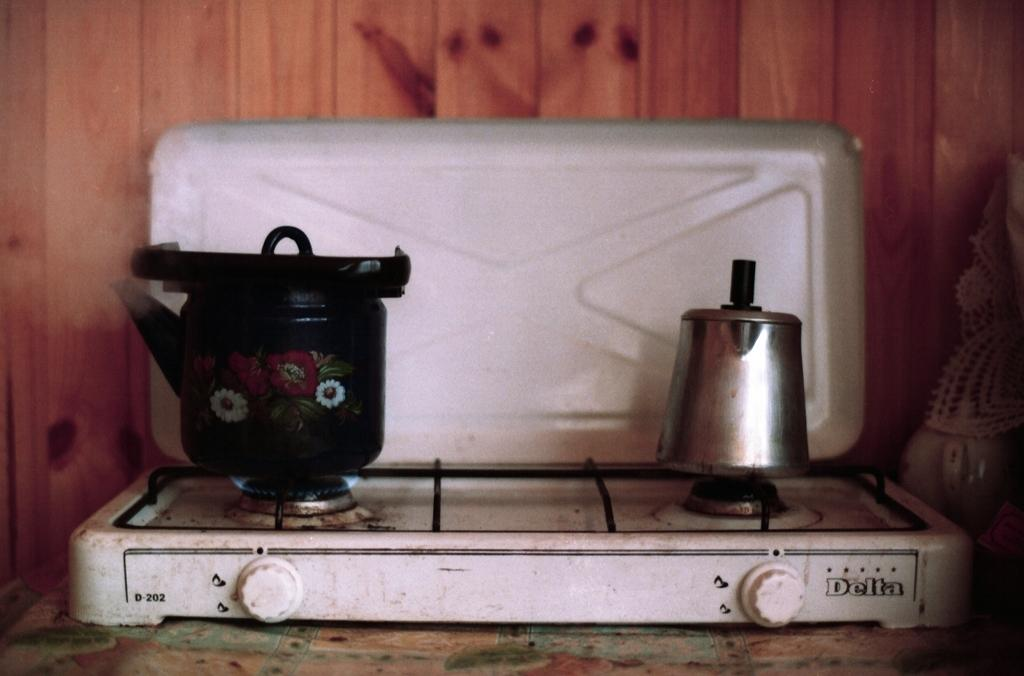<image>
Present a compact description of the photo's key features. The old cooker top shown was made by Delta. 